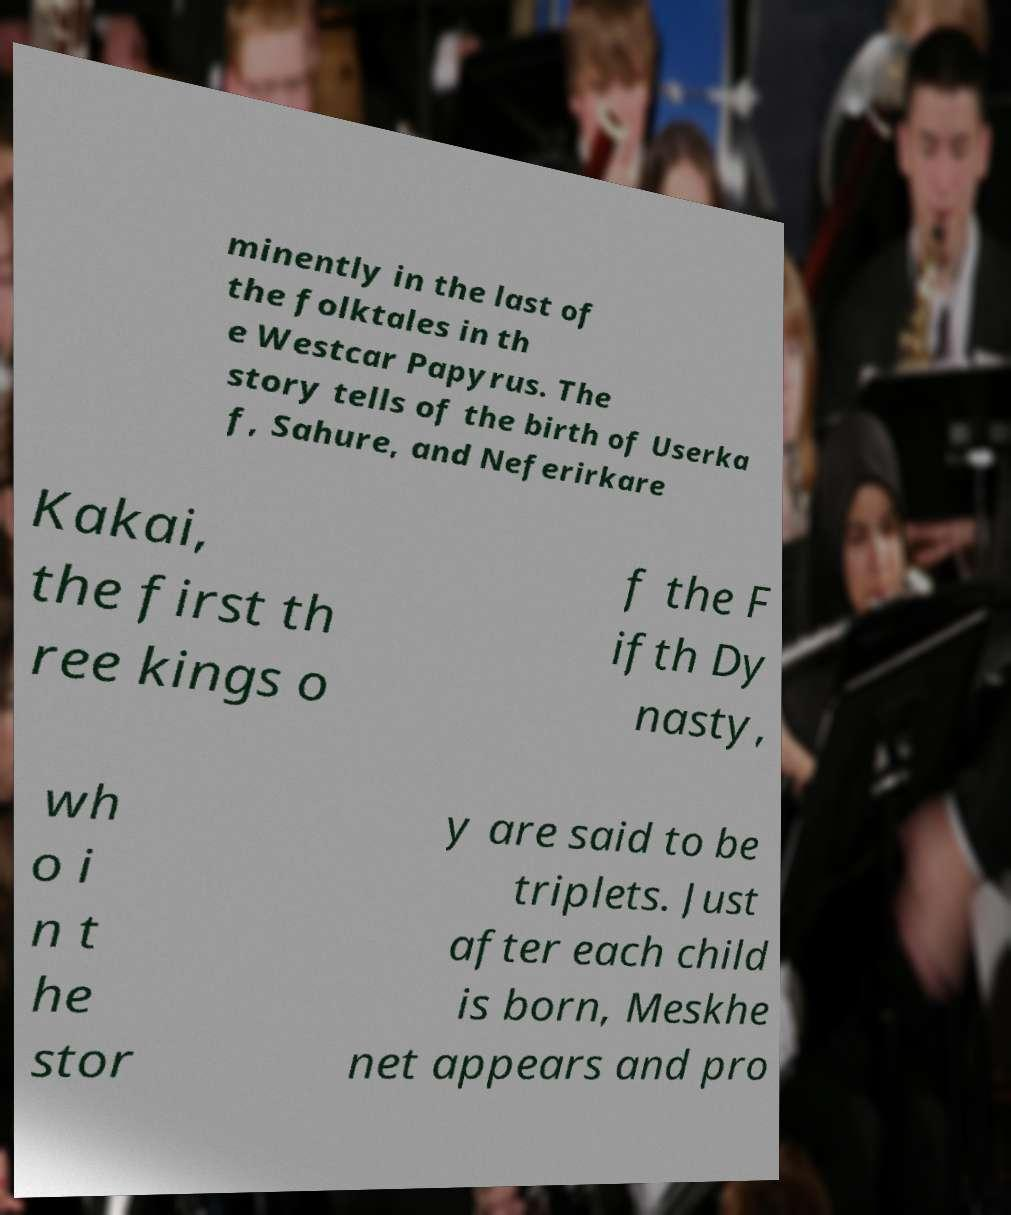Can you read and provide the text displayed in the image?This photo seems to have some interesting text. Can you extract and type it out for me? minently in the last of the folktales in th e Westcar Papyrus. The story tells of the birth of Userka f, Sahure, and Neferirkare Kakai, the first th ree kings o f the F ifth Dy nasty, wh o i n t he stor y are said to be triplets. Just after each child is born, Meskhe net appears and pro 